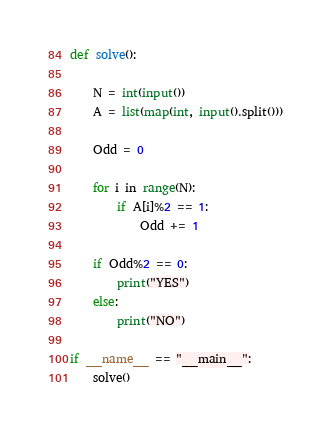Convert code to text. <code><loc_0><loc_0><loc_500><loc_500><_Python_>def solve():

    N = int(input())
    A = list(map(int, input().split()))

    Odd = 0

    for i in range(N):
        if A[i]%2 == 1:
            Odd += 1

    if Odd%2 == 0:
        print("YES")
    else:
        print("NO")

if __name__ == "__main__":
    solve()
</code> 